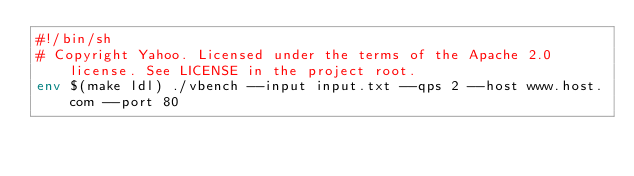<code> <loc_0><loc_0><loc_500><loc_500><_Bash_>#!/bin/sh
# Copyright Yahoo. Licensed under the terms of the Apache 2.0 license. See LICENSE in the project root.
env $(make ldl) ./vbench --input input.txt --qps 2 --host www.host.com --port 80
</code> 